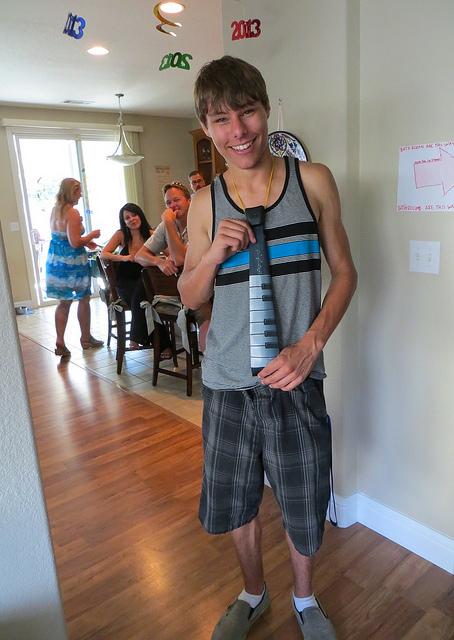Are the people looking at the camera?
Short answer required. Yes. Is he wearing a tie?
Give a very brief answer. Yes. What year is it?
Answer briefly. 2013. 